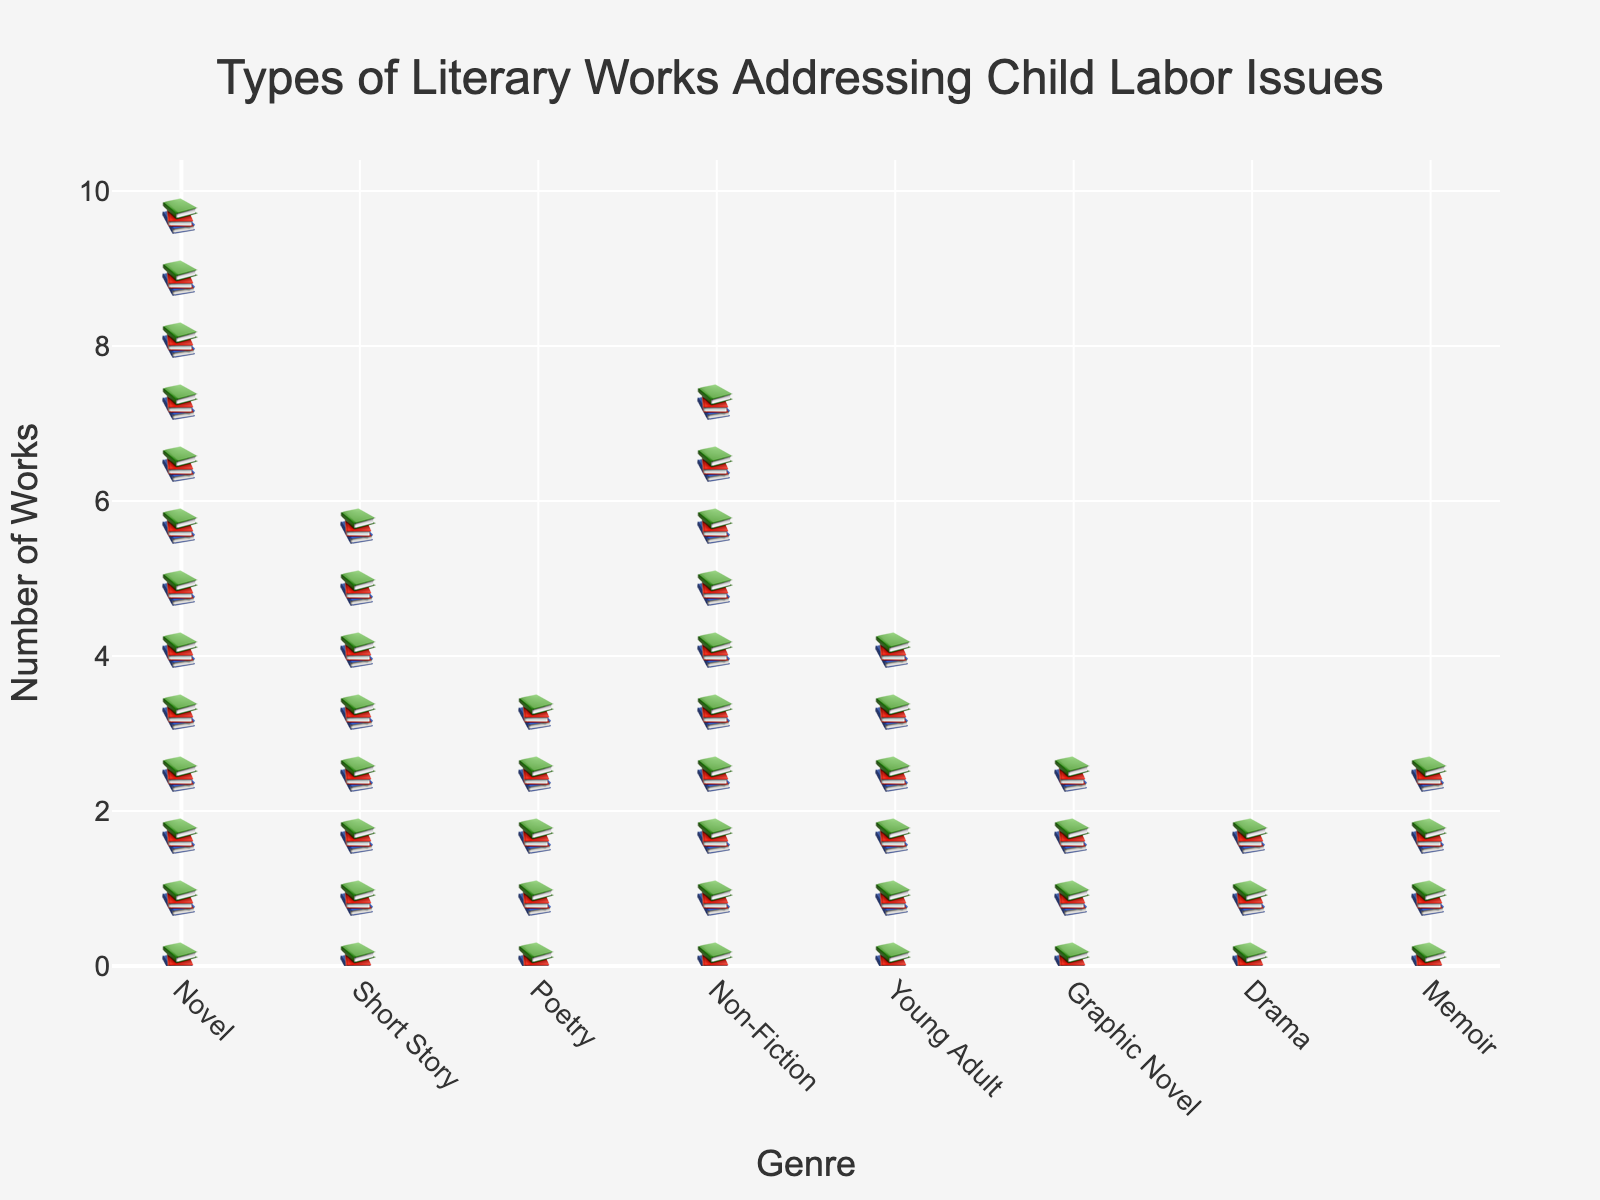Which genre has the most works addressing child labor issues? By viewing the isotype plot, you can see that the genre with the most icons is 'Novel'. This signifies that the Novel genre has the most works addressing child labor issues.
Answer: Novel Which genre has the fewest works addressing child labor issues? By looking at the isotype plot, the genre 'Drama' has the least number of icons. This signifies that the Drama genre has the fewest works.
Answer: Drama How many more works are there in the Non-Fiction genre compared to the Graphic Novel genre? The Non-Fiction genre has 20 works, while the Graphic Novel genre has 8 works. The difference between these two numbers is 20 - 8 = 12.
Answer: 12 Which genres have fewer than 10 works addressing child labor issues? Observing the icons in the isotype plot, the genres with fewer than 10 works are Graphic Novel, Drama, and Memoir as they all have fewer icons.
Answer: Graphic Novel, Drama, Memoir What is the total number of works in the Novel and Short Story genres combined? Summing up the works from these genres: Novel has 25 works and Short Story has 15 works. Therefore, 25 + 15 = 40 works.
Answer: 40 What is the average number of works for genres with more than 10 works? The genres with more than 10 works are Novel (25), Short Story (15), Non-Fiction (20), and Young Adult (12). The total number of works is 25 + 15 + 20 + 12 = 72. There are 4 genres, so the average is 72 / 4 = 18 works.
Answer: 18 Which genre has just over half the number of works as the Novel genre? Novels have 25 works, half of that is 12.5. Short Story, Non-Fiction, and Young Adult are the closest, but the closest to just over half (i.e., more than 12.5) is Non-Fiction with 20 works.
Answer: Non-Fiction How many genres have more than 10 works? By counting the genres with more than 10 icons in the isotype plot, we find that there are four genres: Novel, Short Story, Non-Fiction, and Young Adult.
Answer: 4 Which genre has the same number of works as the Memoir and Drama genres combined? Memoir has 7 works and Drama has 5 works. Combined, that's 7 + 5 = 12 works. The genre with exactly 12 works is Young Adult.
Answer: Young Adult What is the range in the number of works across all genres? The range is the difference between the maximum and minimum values. The genre with the most works is Novel (25), and the genre with the fewest works is Drama (5). The range is 25 - 5 = 20.
Answer: 20 